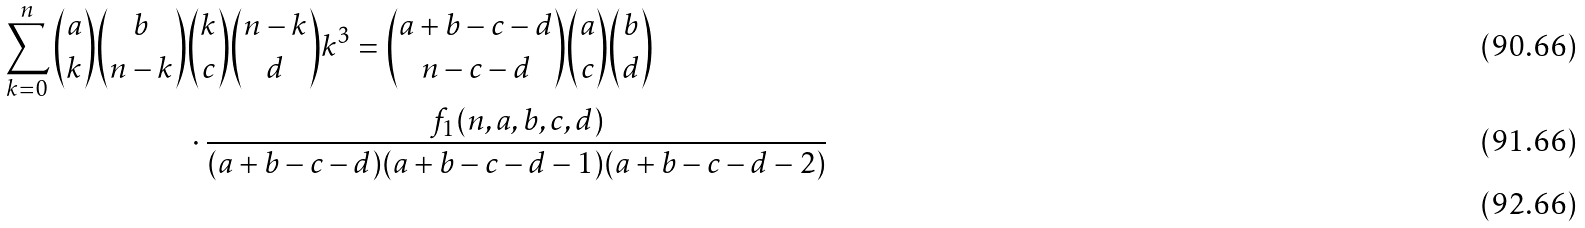Convert formula to latex. <formula><loc_0><loc_0><loc_500><loc_500>\sum _ { k = 0 } ^ { n } \binom { a } { k } \binom { b } { n - k } & \binom { k } { c } \binom { n - k } { d } k ^ { 3 } = \binom { a + b - c - d } { n - c - d } \binom { a } { c } \binom { b } { d } \\ & \cdot \frac { f _ { 1 } ( n , a , b , c , d ) } { ( a + b - c - d ) ( a + b - c - d - 1 ) ( a + b - c - d - 2 ) } \\</formula> 